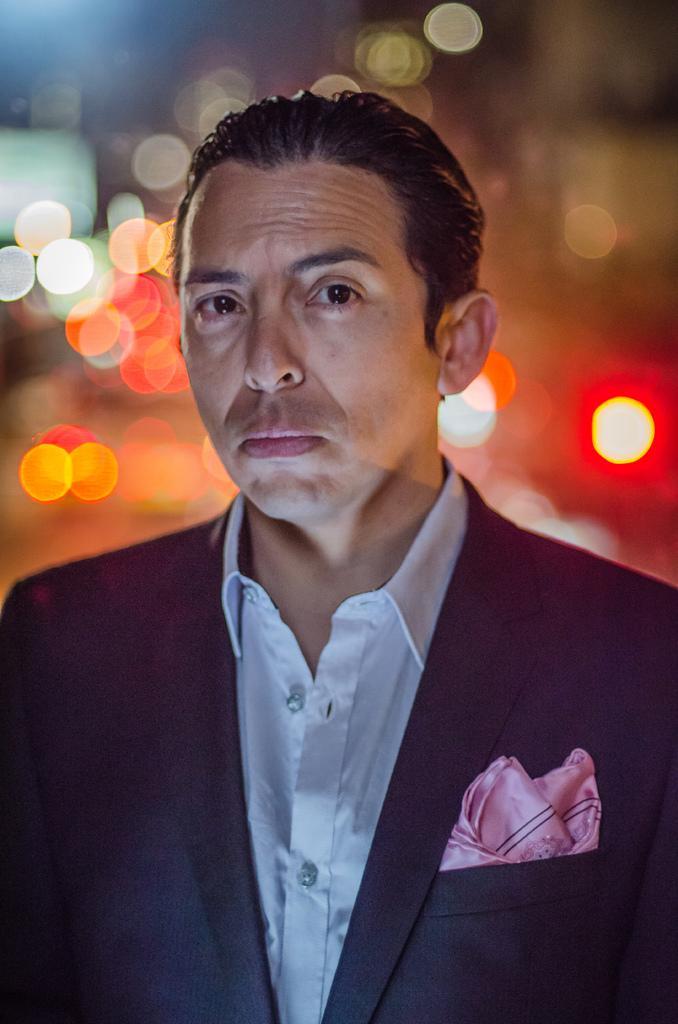Describe this image in one or two sentences. The man in front of the picture is wearing a white shirt and black blazer. He is looking at the camera. Behind him, we see lights. In the background, it is blurred. 